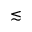<formula> <loc_0><loc_0><loc_500><loc_500>\lesssim</formula> 